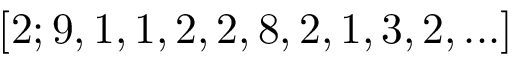<formula> <loc_0><loc_0><loc_500><loc_500>[ 2 ; 9 , 1 , 1 , 2 , 2 , 8 , 2 , 1 , 3 , 2 , \dots ]</formula> 